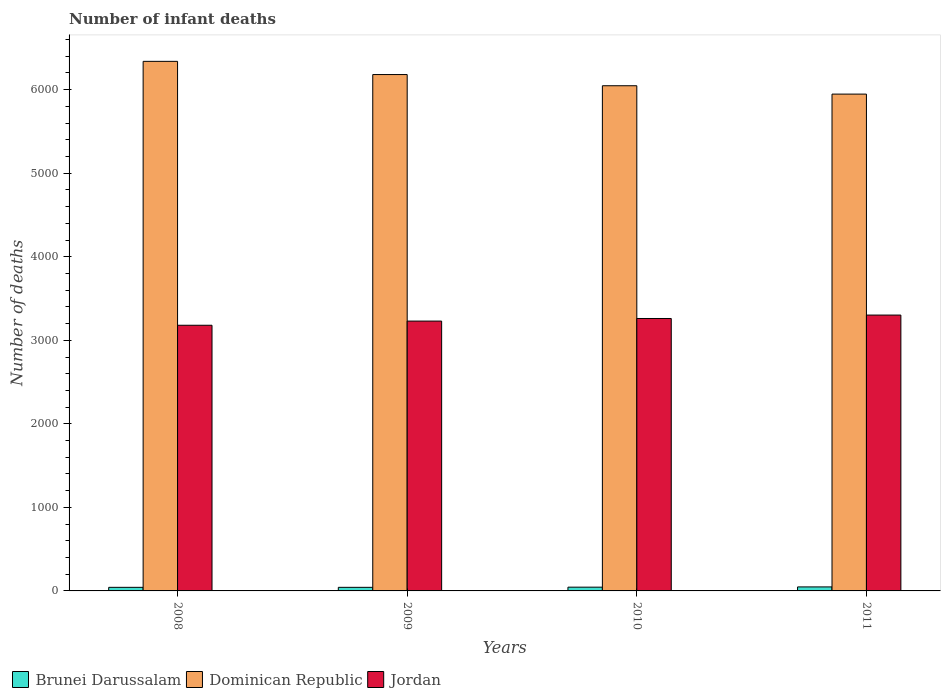How many groups of bars are there?
Provide a short and direct response. 4. Are the number of bars per tick equal to the number of legend labels?
Offer a very short reply. Yes. Are the number of bars on each tick of the X-axis equal?
Your answer should be compact. Yes. How many bars are there on the 2nd tick from the left?
Offer a terse response. 3. What is the label of the 4th group of bars from the left?
Make the answer very short. 2011. What is the number of infant deaths in Brunei Darussalam in 2011?
Make the answer very short. 48. Across all years, what is the maximum number of infant deaths in Dominican Republic?
Give a very brief answer. 6339. Across all years, what is the minimum number of infant deaths in Brunei Darussalam?
Your answer should be very brief. 43. In which year was the number of infant deaths in Jordan minimum?
Offer a very short reply. 2008. What is the total number of infant deaths in Jordan in the graph?
Your answer should be very brief. 1.30e+04. What is the difference between the number of infant deaths in Brunei Darussalam in 2010 and that in 2011?
Offer a very short reply. -3. What is the difference between the number of infant deaths in Brunei Darussalam in 2008 and the number of infant deaths in Jordan in 2011?
Your answer should be very brief. -3259. What is the average number of infant deaths in Brunei Darussalam per year?
Keep it short and to the point. 44.75. In the year 2008, what is the difference between the number of infant deaths in Brunei Darussalam and number of infant deaths in Dominican Republic?
Make the answer very short. -6296. In how many years, is the number of infant deaths in Brunei Darussalam greater than 6400?
Provide a succinct answer. 0. What is the ratio of the number of infant deaths in Dominican Republic in 2008 to that in 2010?
Your response must be concise. 1.05. Is the number of infant deaths in Jordan in 2008 less than that in 2011?
Your answer should be compact. Yes. What is the difference between the highest and the lowest number of infant deaths in Jordan?
Make the answer very short. 122. In how many years, is the number of infant deaths in Brunei Darussalam greater than the average number of infant deaths in Brunei Darussalam taken over all years?
Provide a short and direct response. 2. Is the sum of the number of infant deaths in Dominican Republic in 2010 and 2011 greater than the maximum number of infant deaths in Brunei Darussalam across all years?
Ensure brevity in your answer.  Yes. What does the 2nd bar from the left in 2009 represents?
Provide a short and direct response. Dominican Republic. What does the 1st bar from the right in 2008 represents?
Make the answer very short. Jordan. How many bars are there?
Provide a short and direct response. 12. Are all the bars in the graph horizontal?
Keep it short and to the point. No. Does the graph contain any zero values?
Your answer should be compact. No. Where does the legend appear in the graph?
Your answer should be very brief. Bottom left. How are the legend labels stacked?
Your answer should be compact. Horizontal. What is the title of the graph?
Ensure brevity in your answer.  Number of infant deaths. Does "Cuba" appear as one of the legend labels in the graph?
Offer a very short reply. No. What is the label or title of the X-axis?
Offer a terse response. Years. What is the label or title of the Y-axis?
Keep it short and to the point. Number of deaths. What is the Number of deaths of Brunei Darussalam in 2008?
Your answer should be compact. 43. What is the Number of deaths in Dominican Republic in 2008?
Your answer should be very brief. 6339. What is the Number of deaths in Jordan in 2008?
Ensure brevity in your answer.  3180. What is the Number of deaths of Brunei Darussalam in 2009?
Offer a very short reply. 43. What is the Number of deaths in Dominican Republic in 2009?
Provide a short and direct response. 6181. What is the Number of deaths of Jordan in 2009?
Your answer should be compact. 3230. What is the Number of deaths of Dominican Republic in 2010?
Make the answer very short. 6047. What is the Number of deaths in Jordan in 2010?
Your answer should be compact. 3261. What is the Number of deaths in Dominican Republic in 2011?
Offer a very short reply. 5947. What is the Number of deaths in Jordan in 2011?
Offer a very short reply. 3302. Across all years, what is the maximum Number of deaths of Dominican Republic?
Your response must be concise. 6339. Across all years, what is the maximum Number of deaths of Jordan?
Offer a terse response. 3302. Across all years, what is the minimum Number of deaths in Brunei Darussalam?
Provide a succinct answer. 43. Across all years, what is the minimum Number of deaths in Dominican Republic?
Provide a short and direct response. 5947. Across all years, what is the minimum Number of deaths in Jordan?
Provide a short and direct response. 3180. What is the total Number of deaths in Brunei Darussalam in the graph?
Your response must be concise. 179. What is the total Number of deaths of Dominican Republic in the graph?
Your answer should be very brief. 2.45e+04. What is the total Number of deaths in Jordan in the graph?
Provide a succinct answer. 1.30e+04. What is the difference between the Number of deaths of Brunei Darussalam in 2008 and that in 2009?
Your response must be concise. 0. What is the difference between the Number of deaths of Dominican Republic in 2008 and that in 2009?
Your answer should be very brief. 158. What is the difference between the Number of deaths in Jordan in 2008 and that in 2009?
Your answer should be very brief. -50. What is the difference between the Number of deaths in Dominican Republic in 2008 and that in 2010?
Offer a very short reply. 292. What is the difference between the Number of deaths of Jordan in 2008 and that in 2010?
Your response must be concise. -81. What is the difference between the Number of deaths in Brunei Darussalam in 2008 and that in 2011?
Keep it short and to the point. -5. What is the difference between the Number of deaths of Dominican Republic in 2008 and that in 2011?
Provide a short and direct response. 392. What is the difference between the Number of deaths in Jordan in 2008 and that in 2011?
Offer a terse response. -122. What is the difference between the Number of deaths of Brunei Darussalam in 2009 and that in 2010?
Keep it short and to the point. -2. What is the difference between the Number of deaths of Dominican Republic in 2009 and that in 2010?
Provide a short and direct response. 134. What is the difference between the Number of deaths in Jordan in 2009 and that in 2010?
Make the answer very short. -31. What is the difference between the Number of deaths of Dominican Republic in 2009 and that in 2011?
Provide a succinct answer. 234. What is the difference between the Number of deaths of Jordan in 2009 and that in 2011?
Your answer should be very brief. -72. What is the difference between the Number of deaths in Dominican Republic in 2010 and that in 2011?
Ensure brevity in your answer.  100. What is the difference between the Number of deaths in Jordan in 2010 and that in 2011?
Offer a very short reply. -41. What is the difference between the Number of deaths of Brunei Darussalam in 2008 and the Number of deaths of Dominican Republic in 2009?
Your response must be concise. -6138. What is the difference between the Number of deaths in Brunei Darussalam in 2008 and the Number of deaths in Jordan in 2009?
Your answer should be very brief. -3187. What is the difference between the Number of deaths in Dominican Republic in 2008 and the Number of deaths in Jordan in 2009?
Provide a succinct answer. 3109. What is the difference between the Number of deaths in Brunei Darussalam in 2008 and the Number of deaths in Dominican Republic in 2010?
Provide a succinct answer. -6004. What is the difference between the Number of deaths in Brunei Darussalam in 2008 and the Number of deaths in Jordan in 2010?
Make the answer very short. -3218. What is the difference between the Number of deaths in Dominican Republic in 2008 and the Number of deaths in Jordan in 2010?
Make the answer very short. 3078. What is the difference between the Number of deaths in Brunei Darussalam in 2008 and the Number of deaths in Dominican Republic in 2011?
Make the answer very short. -5904. What is the difference between the Number of deaths of Brunei Darussalam in 2008 and the Number of deaths of Jordan in 2011?
Your answer should be very brief. -3259. What is the difference between the Number of deaths in Dominican Republic in 2008 and the Number of deaths in Jordan in 2011?
Your response must be concise. 3037. What is the difference between the Number of deaths in Brunei Darussalam in 2009 and the Number of deaths in Dominican Republic in 2010?
Give a very brief answer. -6004. What is the difference between the Number of deaths in Brunei Darussalam in 2009 and the Number of deaths in Jordan in 2010?
Provide a short and direct response. -3218. What is the difference between the Number of deaths of Dominican Republic in 2009 and the Number of deaths of Jordan in 2010?
Offer a very short reply. 2920. What is the difference between the Number of deaths of Brunei Darussalam in 2009 and the Number of deaths of Dominican Republic in 2011?
Provide a succinct answer. -5904. What is the difference between the Number of deaths in Brunei Darussalam in 2009 and the Number of deaths in Jordan in 2011?
Keep it short and to the point. -3259. What is the difference between the Number of deaths of Dominican Republic in 2009 and the Number of deaths of Jordan in 2011?
Your answer should be compact. 2879. What is the difference between the Number of deaths of Brunei Darussalam in 2010 and the Number of deaths of Dominican Republic in 2011?
Your answer should be compact. -5902. What is the difference between the Number of deaths in Brunei Darussalam in 2010 and the Number of deaths in Jordan in 2011?
Keep it short and to the point. -3257. What is the difference between the Number of deaths of Dominican Republic in 2010 and the Number of deaths of Jordan in 2011?
Your answer should be compact. 2745. What is the average Number of deaths in Brunei Darussalam per year?
Your response must be concise. 44.75. What is the average Number of deaths of Dominican Republic per year?
Your answer should be compact. 6128.5. What is the average Number of deaths of Jordan per year?
Give a very brief answer. 3243.25. In the year 2008, what is the difference between the Number of deaths of Brunei Darussalam and Number of deaths of Dominican Republic?
Your response must be concise. -6296. In the year 2008, what is the difference between the Number of deaths in Brunei Darussalam and Number of deaths in Jordan?
Offer a terse response. -3137. In the year 2008, what is the difference between the Number of deaths in Dominican Republic and Number of deaths in Jordan?
Give a very brief answer. 3159. In the year 2009, what is the difference between the Number of deaths of Brunei Darussalam and Number of deaths of Dominican Republic?
Offer a terse response. -6138. In the year 2009, what is the difference between the Number of deaths in Brunei Darussalam and Number of deaths in Jordan?
Ensure brevity in your answer.  -3187. In the year 2009, what is the difference between the Number of deaths of Dominican Republic and Number of deaths of Jordan?
Keep it short and to the point. 2951. In the year 2010, what is the difference between the Number of deaths of Brunei Darussalam and Number of deaths of Dominican Republic?
Offer a very short reply. -6002. In the year 2010, what is the difference between the Number of deaths in Brunei Darussalam and Number of deaths in Jordan?
Your answer should be very brief. -3216. In the year 2010, what is the difference between the Number of deaths in Dominican Republic and Number of deaths in Jordan?
Your answer should be compact. 2786. In the year 2011, what is the difference between the Number of deaths of Brunei Darussalam and Number of deaths of Dominican Republic?
Give a very brief answer. -5899. In the year 2011, what is the difference between the Number of deaths in Brunei Darussalam and Number of deaths in Jordan?
Offer a terse response. -3254. In the year 2011, what is the difference between the Number of deaths in Dominican Republic and Number of deaths in Jordan?
Your answer should be compact. 2645. What is the ratio of the Number of deaths of Dominican Republic in 2008 to that in 2009?
Provide a short and direct response. 1.03. What is the ratio of the Number of deaths of Jordan in 2008 to that in 2009?
Give a very brief answer. 0.98. What is the ratio of the Number of deaths of Brunei Darussalam in 2008 to that in 2010?
Ensure brevity in your answer.  0.96. What is the ratio of the Number of deaths in Dominican Republic in 2008 to that in 2010?
Your answer should be very brief. 1.05. What is the ratio of the Number of deaths of Jordan in 2008 to that in 2010?
Offer a terse response. 0.98. What is the ratio of the Number of deaths in Brunei Darussalam in 2008 to that in 2011?
Provide a short and direct response. 0.9. What is the ratio of the Number of deaths in Dominican Republic in 2008 to that in 2011?
Your answer should be very brief. 1.07. What is the ratio of the Number of deaths in Jordan in 2008 to that in 2011?
Provide a short and direct response. 0.96. What is the ratio of the Number of deaths of Brunei Darussalam in 2009 to that in 2010?
Your response must be concise. 0.96. What is the ratio of the Number of deaths in Dominican Republic in 2009 to that in 2010?
Provide a succinct answer. 1.02. What is the ratio of the Number of deaths of Jordan in 2009 to that in 2010?
Give a very brief answer. 0.99. What is the ratio of the Number of deaths in Brunei Darussalam in 2009 to that in 2011?
Ensure brevity in your answer.  0.9. What is the ratio of the Number of deaths in Dominican Republic in 2009 to that in 2011?
Give a very brief answer. 1.04. What is the ratio of the Number of deaths in Jordan in 2009 to that in 2011?
Keep it short and to the point. 0.98. What is the ratio of the Number of deaths in Brunei Darussalam in 2010 to that in 2011?
Your answer should be compact. 0.94. What is the ratio of the Number of deaths of Dominican Republic in 2010 to that in 2011?
Keep it short and to the point. 1.02. What is the ratio of the Number of deaths in Jordan in 2010 to that in 2011?
Offer a very short reply. 0.99. What is the difference between the highest and the second highest Number of deaths of Brunei Darussalam?
Ensure brevity in your answer.  3. What is the difference between the highest and the second highest Number of deaths of Dominican Republic?
Your response must be concise. 158. What is the difference between the highest and the second highest Number of deaths of Jordan?
Your answer should be very brief. 41. What is the difference between the highest and the lowest Number of deaths of Brunei Darussalam?
Make the answer very short. 5. What is the difference between the highest and the lowest Number of deaths in Dominican Republic?
Offer a terse response. 392. What is the difference between the highest and the lowest Number of deaths of Jordan?
Give a very brief answer. 122. 